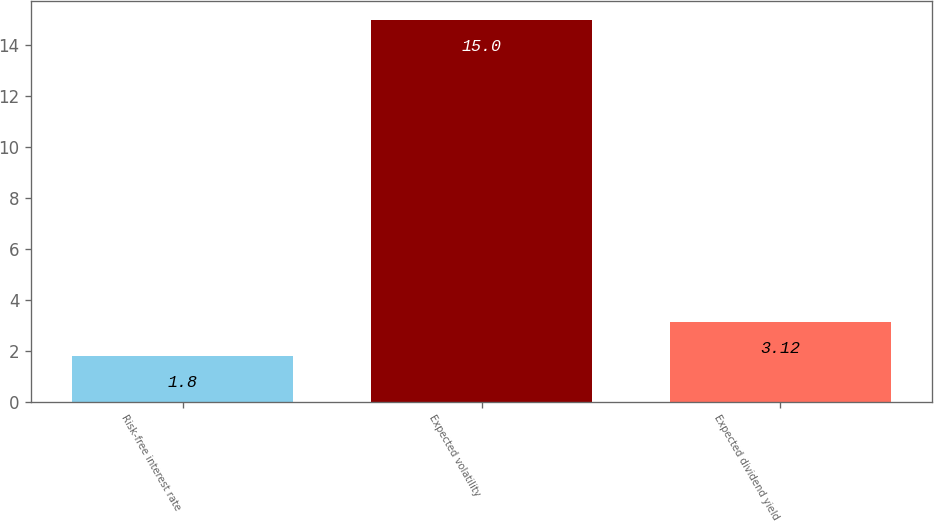Convert chart. <chart><loc_0><loc_0><loc_500><loc_500><bar_chart><fcel>Risk-free interest rate<fcel>Expected volatility<fcel>Expected dividend yield<nl><fcel>1.8<fcel>15<fcel>3.12<nl></chart> 